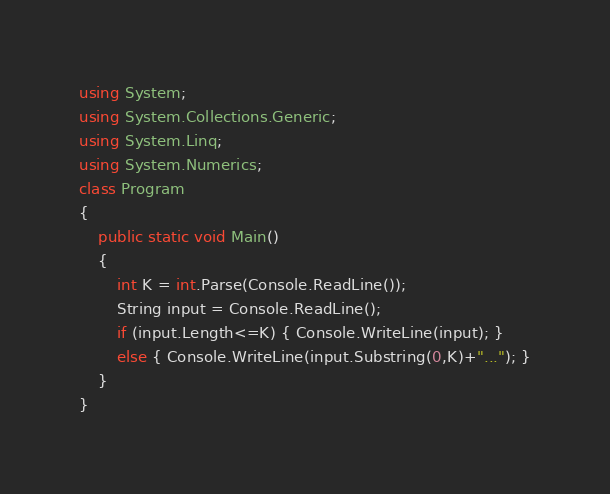<code> <loc_0><loc_0><loc_500><loc_500><_C#_>using System;
using System.Collections.Generic;
using System.Linq;
using System.Numerics;
class Program
{
    public static void Main()
    {
        int K = int.Parse(Console.ReadLine());
        String input = Console.ReadLine();
        if (input.Length<=K) { Console.WriteLine(input); }
        else { Console.WriteLine(input.Substring(0,K)+"..."); }
    }
}</code> 